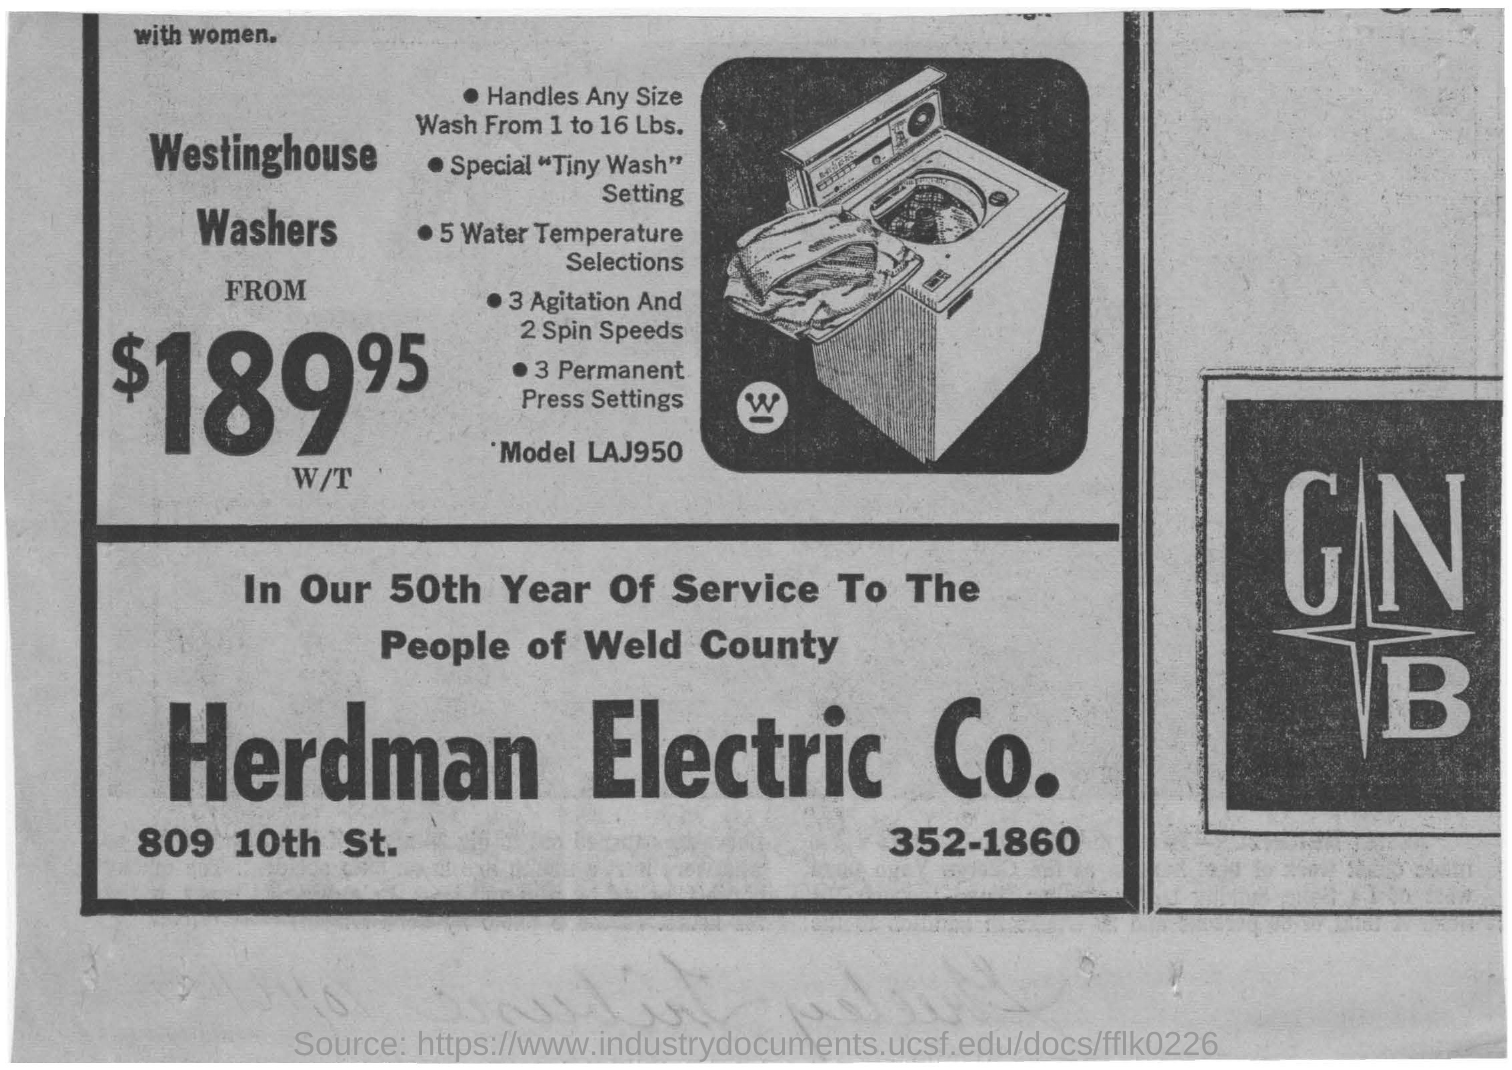Point out several critical features in this image. The model mentioned is Model LAJ950. The company depicted in the image is Herdman Electric Company. 